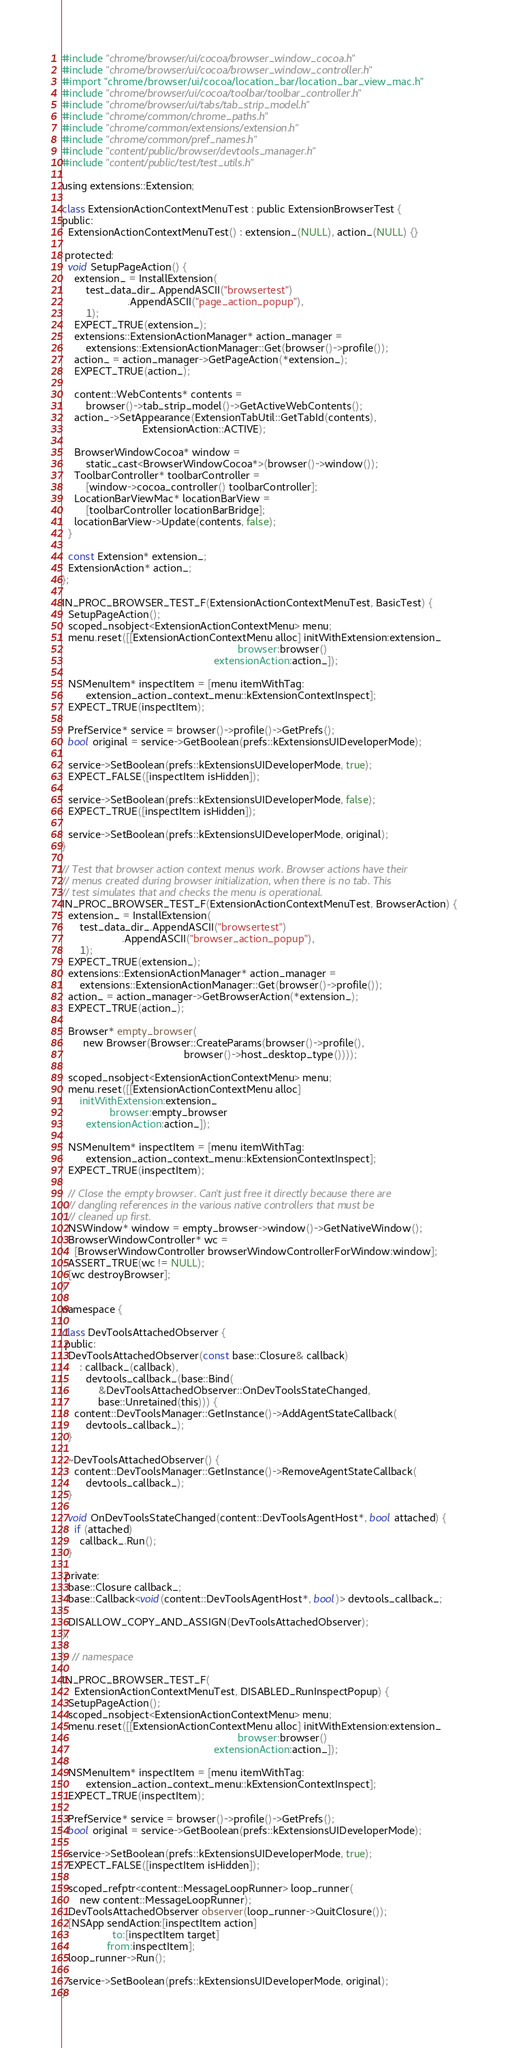<code> <loc_0><loc_0><loc_500><loc_500><_ObjectiveC_>#include "chrome/browser/ui/cocoa/browser_window_cocoa.h"
#include "chrome/browser/ui/cocoa/browser_window_controller.h"
#import "chrome/browser/ui/cocoa/location_bar/location_bar_view_mac.h"
#include "chrome/browser/ui/cocoa/toolbar/toolbar_controller.h"
#include "chrome/browser/ui/tabs/tab_strip_model.h"
#include "chrome/common/chrome_paths.h"
#include "chrome/common/extensions/extension.h"
#include "chrome/common/pref_names.h"
#include "content/public/browser/devtools_manager.h"
#include "content/public/test/test_utils.h"

using extensions::Extension;

class ExtensionActionContextMenuTest : public ExtensionBrowserTest {
public:
  ExtensionActionContextMenuTest() : extension_(NULL), action_(NULL) {}

 protected:
  void SetupPageAction() {
    extension_ = InstallExtension(
        test_data_dir_.AppendASCII("browsertest")
                      .AppendASCII("page_action_popup"),
        1);
    EXPECT_TRUE(extension_);
    extensions::ExtensionActionManager* action_manager =
        extensions::ExtensionActionManager::Get(browser()->profile());
    action_ = action_manager->GetPageAction(*extension_);
    EXPECT_TRUE(action_);

    content::WebContents* contents =
        browser()->tab_strip_model()->GetActiveWebContents();
    action_->SetAppearance(ExtensionTabUtil::GetTabId(contents),
                           ExtensionAction::ACTIVE);

    BrowserWindowCocoa* window =
        static_cast<BrowserWindowCocoa*>(browser()->window());
    ToolbarController* toolbarController =
        [window->cocoa_controller() toolbarController];
    LocationBarViewMac* locationBarView =
        [toolbarController locationBarBridge];
    locationBarView->Update(contents, false);
  }

  const Extension* extension_;
  ExtensionAction* action_;
};

IN_PROC_BROWSER_TEST_F(ExtensionActionContextMenuTest, BasicTest) {
  SetupPageAction();
  scoped_nsobject<ExtensionActionContextMenu> menu;
  menu.reset([[ExtensionActionContextMenu alloc] initWithExtension:extension_
                                                           browser:browser()
                                                   extensionAction:action_]);

  NSMenuItem* inspectItem = [menu itemWithTag:
        extension_action_context_menu::kExtensionContextInspect];
  EXPECT_TRUE(inspectItem);

  PrefService* service = browser()->profile()->GetPrefs();
  bool original = service->GetBoolean(prefs::kExtensionsUIDeveloperMode);

  service->SetBoolean(prefs::kExtensionsUIDeveloperMode, true);
  EXPECT_FALSE([inspectItem isHidden]);

  service->SetBoolean(prefs::kExtensionsUIDeveloperMode, false);
  EXPECT_TRUE([inspectItem isHidden]);

  service->SetBoolean(prefs::kExtensionsUIDeveloperMode, original);
}

// Test that browser action context menus work. Browser actions have their
// menus created during browser initialization, when there is no tab. This
// test simulates that and checks the menu is operational.
IN_PROC_BROWSER_TEST_F(ExtensionActionContextMenuTest, BrowserAction) {
  extension_ = InstallExtension(
      test_data_dir_.AppendASCII("browsertest")
                    .AppendASCII("browser_action_popup"),
      1);
  EXPECT_TRUE(extension_);
  extensions::ExtensionActionManager* action_manager =
      extensions::ExtensionActionManager::Get(browser()->profile());
  action_ = action_manager->GetBrowserAction(*extension_);
  EXPECT_TRUE(action_);

  Browser* empty_browser(
       new Browser(Browser::CreateParams(browser()->profile(),
                                         browser()->host_desktop_type())));

  scoped_nsobject<ExtensionActionContextMenu> menu;
  menu.reset([[ExtensionActionContextMenu alloc]
      initWithExtension:extension_
                browser:empty_browser
        extensionAction:action_]);

  NSMenuItem* inspectItem = [menu itemWithTag:
        extension_action_context_menu::kExtensionContextInspect];
  EXPECT_TRUE(inspectItem);

  // Close the empty browser. Can't just free it directly because there are
  // dangling references in the various native controllers that must be
  // cleaned up first.
  NSWindow* window = empty_browser->window()->GetNativeWindow();
  BrowserWindowController* wc =
    [BrowserWindowController browserWindowControllerForWindow:window];
  ASSERT_TRUE(wc != NULL);
  [wc destroyBrowser];
}

namespace {

class DevToolsAttachedObserver {
 public:
  DevToolsAttachedObserver(const base::Closure& callback)
      : callback_(callback),
        devtools_callback_(base::Bind(
            &DevToolsAttachedObserver::OnDevToolsStateChanged,
            base::Unretained(this))) {
    content::DevToolsManager::GetInstance()->AddAgentStateCallback(
        devtools_callback_);
  }

  ~DevToolsAttachedObserver() {
    content::DevToolsManager::GetInstance()->RemoveAgentStateCallback(
        devtools_callback_);
  }

  void OnDevToolsStateChanged(content::DevToolsAgentHost*, bool attached) {
    if (attached)
      callback_.Run();
  }

 private:
  base::Closure callback_;
  base::Callback<void(content::DevToolsAgentHost*, bool)> devtools_callback_;

  DISALLOW_COPY_AND_ASSIGN(DevToolsAttachedObserver);
};

}  // namespace

IN_PROC_BROWSER_TEST_F(
    ExtensionActionContextMenuTest, DISABLED_RunInspectPopup) {
  SetupPageAction();
  scoped_nsobject<ExtensionActionContextMenu> menu;
  menu.reset([[ExtensionActionContextMenu alloc] initWithExtension:extension_
                                                           browser:browser()
                                                   extensionAction:action_]);

  NSMenuItem* inspectItem = [menu itemWithTag:
        extension_action_context_menu::kExtensionContextInspect];
  EXPECT_TRUE(inspectItem);

  PrefService* service = browser()->profile()->GetPrefs();
  bool original = service->GetBoolean(prefs::kExtensionsUIDeveloperMode);

  service->SetBoolean(prefs::kExtensionsUIDeveloperMode, true);
  EXPECT_FALSE([inspectItem isHidden]);

  scoped_refptr<content::MessageLoopRunner> loop_runner(
      new content::MessageLoopRunner);
  DevToolsAttachedObserver observer(loop_runner->QuitClosure());
  [NSApp sendAction:[inspectItem action]
                 to:[inspectItem target]
               from:inspectItem];
  loop_runner->Run();

  service->SetBoolean(prefs::kExtensionsUIDeveloperMode, original);
}
</code> 